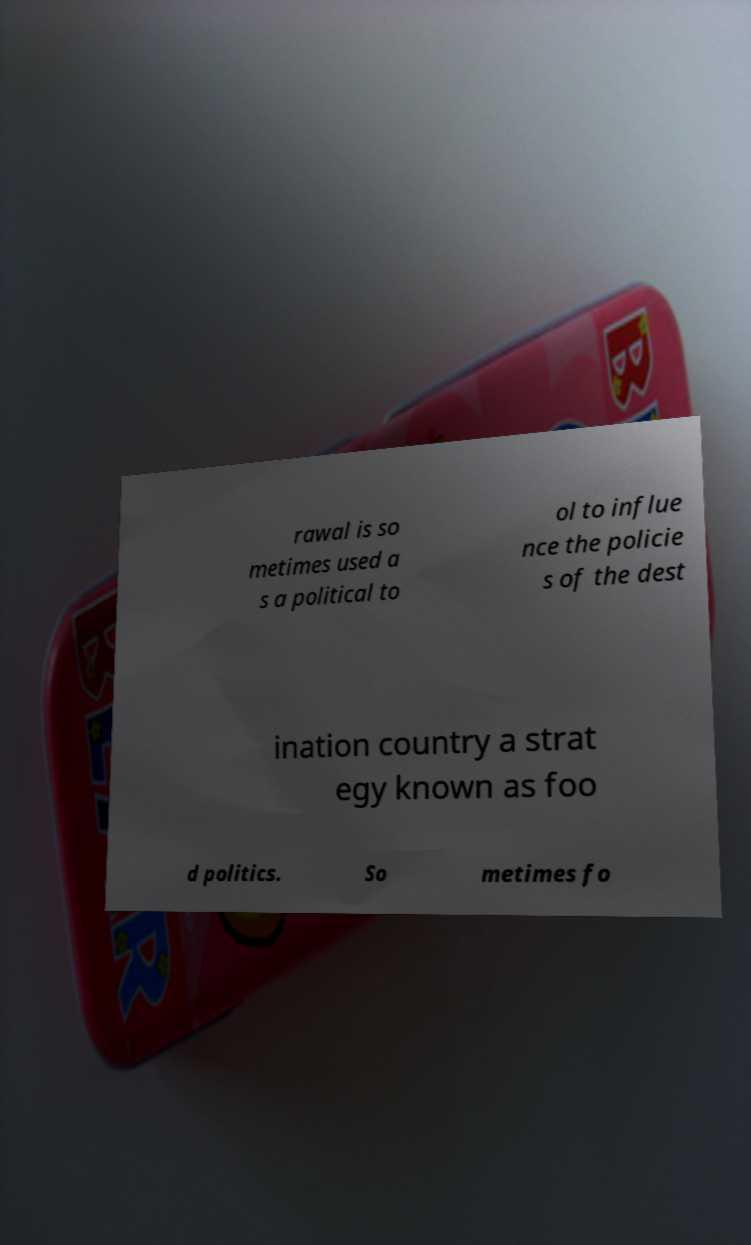There's text embedded in this image that I need extracted. Can you transcribe it verbatim? rawal is so metimes used a s a political to ol to influe nce the policie s of the dest ination country a strat egy known as foo d politics. So metimes fo 